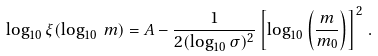Convert formula to latex. <formula><loc_0><loc_0><loc_500><loc_500>\log _ { 1 0 } \xi ( \log _ { 1 0 } \, m ) = A - \frac { 1 } { 2 ( \log _ { 1 0 } \sigma ) ^ { 2 } } \left [ \log _ { 1 0 } \left ( \frac { m } { m _ { 0 } } \right ) \right ] ^ { 2 } \, .</formula> 